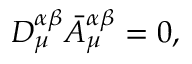<formula> <loc_0><loc_0><loc_500><loc_500>D _ { \mu } ^ { \alpha \beta } \bar { A } _ { \mu } ^ { \alpha \beta } = 0 ,</formula> 